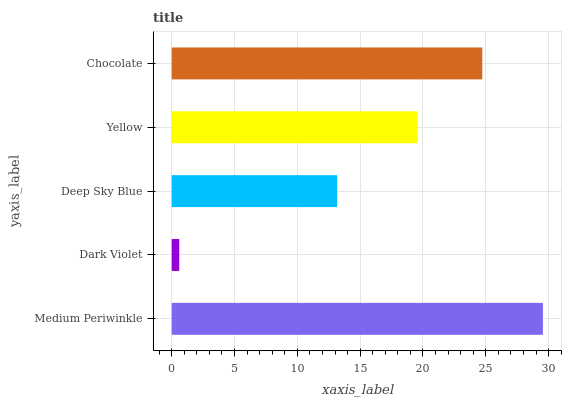Is Dark Violet the minimum?
Answer yes or no. Yes. Is Medium Periwinkle the maximum?
Answer yes or no. Yes. Is Deep Sky Blue the minimum?
Answer yes or no. No. Is Deep Sky Blue the maximum?
Answer yes or no. No. Is Deep Sky Blue greater than Dark Violet?
Answer yes or no. Yes. Is Dark Violet less than Deep Sky Blue?
Answer yes or no. Yes. Is Dark Violet greater than Deep Sky Blue?
Answer yes or no. No. Is Deep Sky Blue less than Dark Violet?
Answer yes or no. No. Is Yellow the high median?
Answer yes or no. Yes. Is Yellow the low median?
Answer yes or no. Yes. Is Deep Sky Blue the high median?
Answer yes or no. No. Is Dark Violet the low median?
Answer yes or no. No. 